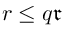Convert formula to latex. <formula><loc_0><loc_0><loc_500><loc_500>r \leq q \mathfrak { r }</formula> 